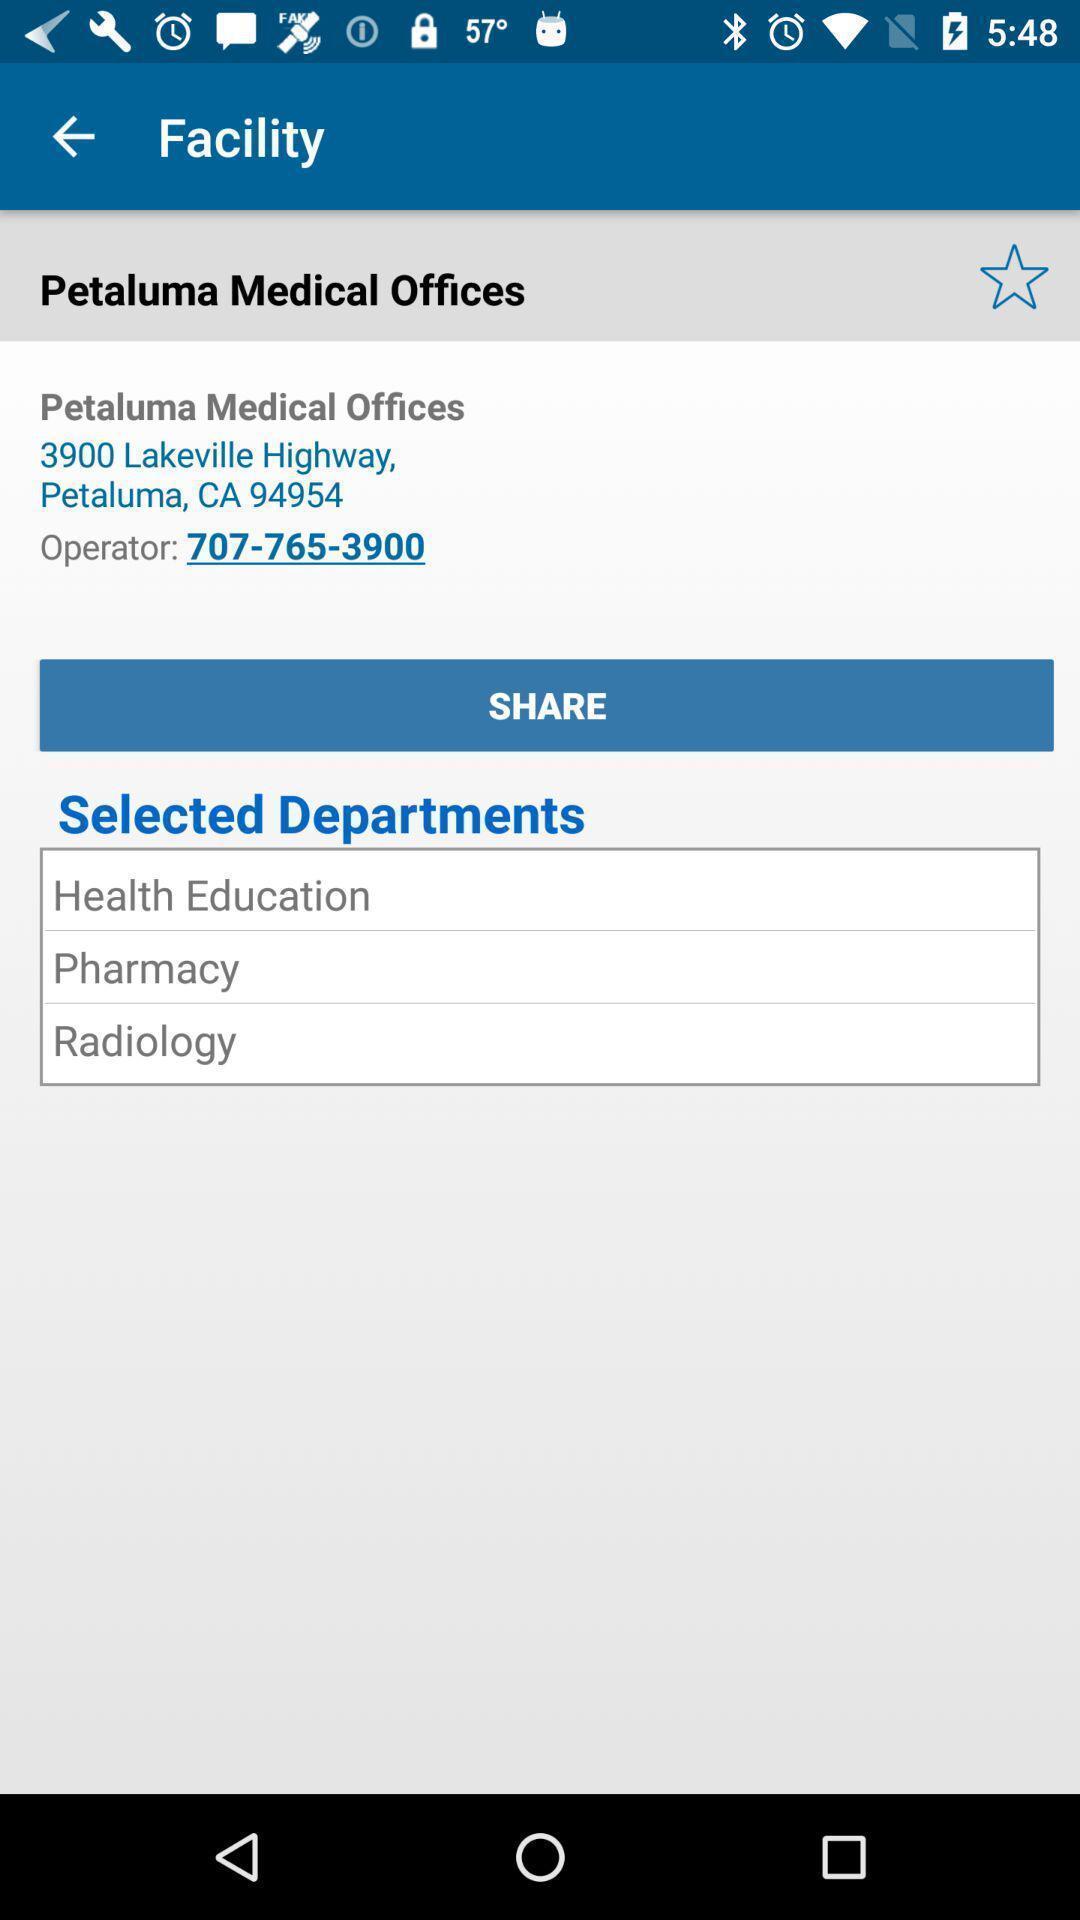Provide a description of this screenshot. Page displaying the address of a company. 